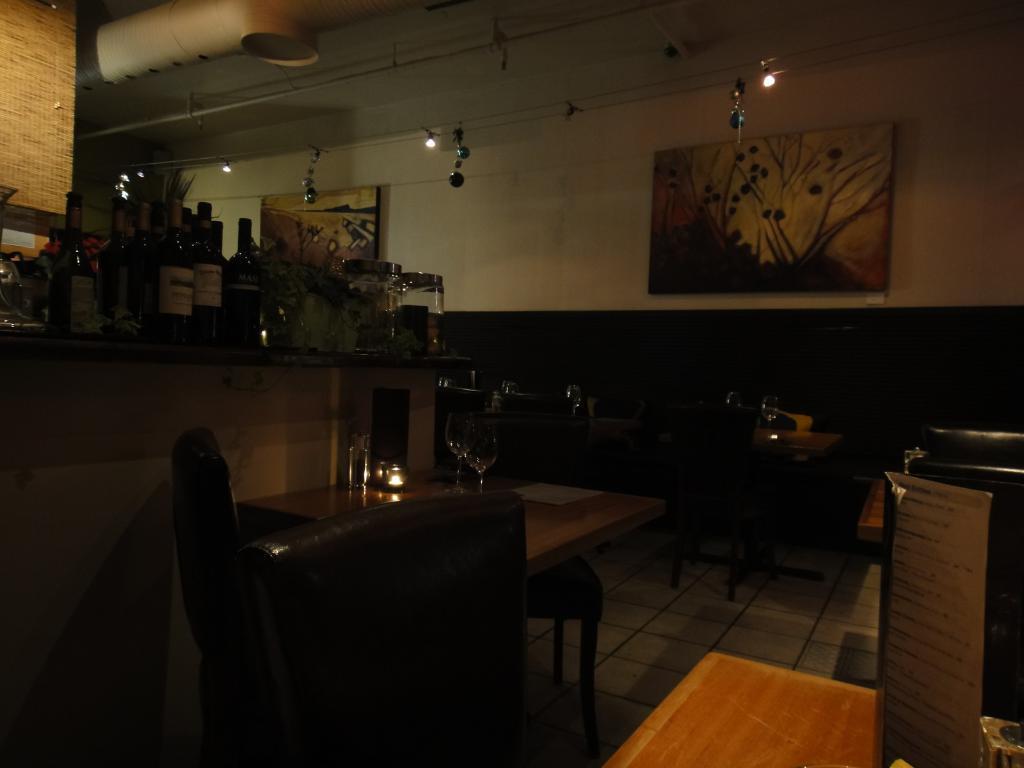In one or two sentences, can you explain what this image depicts? In this image I can see few glasses on the tables. To the side of the tables I can see the chairs. To the right I can see the board on the table. In the background I can see wine bottles and containers on the countertop. I can see some boards to the wall and there are lights in the top. 